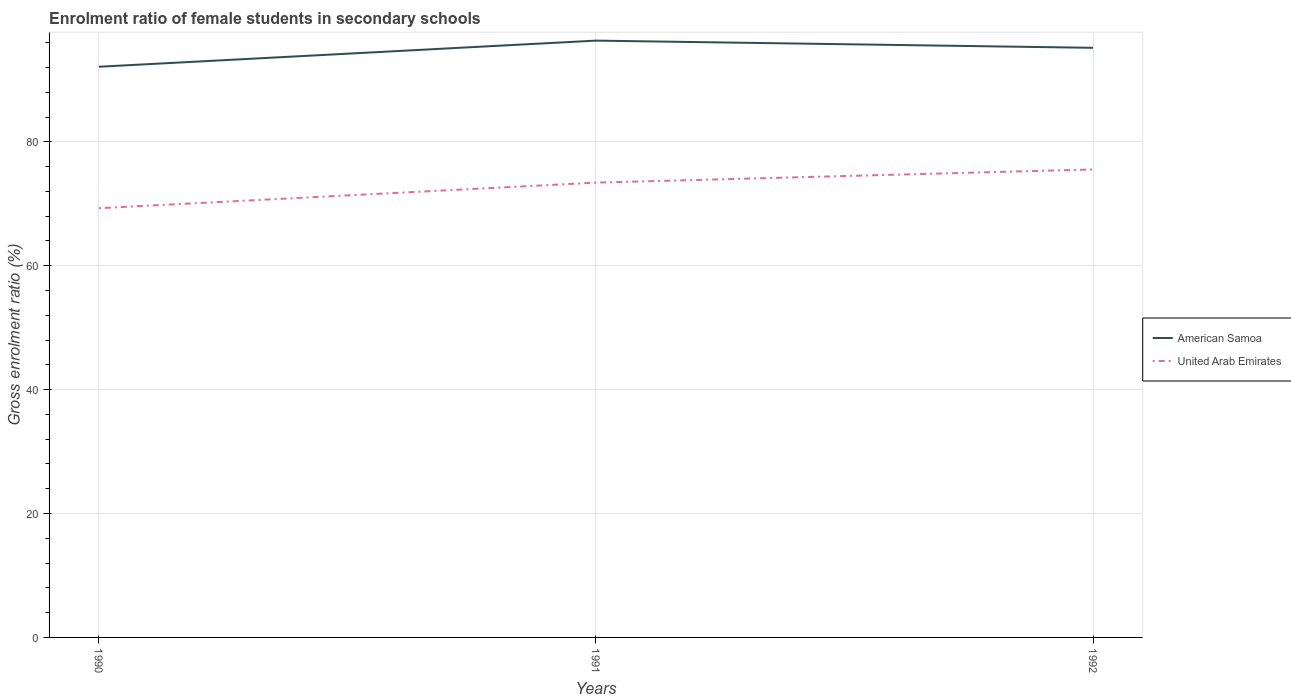Does the line corresponding to American Samoa intersect with the line corresponding to United Arab Emirates?
Ensure brevity in your answer.  No. Is the number of lines equal to the number of legend labels?
Ensure brevity in your answer.  Yes. Across all years, what is the maximum enrolment ratio of female students in secondary schools in United Arab Emirates?
Provide a succinct answer. 69.29. In which year was the enrolment ratio of female students in secondary schools in United Arab Emirates maximum?
Your response must be concise. 1990. What is the total enrolment ratio of female students in secondary schools in American Samoa in the graph?
Provide a succinct answer. -3.06. What is the difference between the highest and the second highest enrolment ratio of female students in secondary schools in American Samoa?
Your response must be concise. 4.22. Is the enrolment ratio of female students in secondary schools in United Arab Emirates strictly greater than the enrolment ratio of female students in secondary schools in American Samoa over the years?
Offer a very short reply. Yes. What is the difference between two consecutive major ticks on the Y-axis?
Your answer should be compact. 20. Are the values on the major ticks of Y-axis written in scientific E-notation?
Give a very brief answer. No. Does the graph contain grids?
Your response must be concise. Yes. How many legend labels are there?
Ensure brevity in your answer.  2. How are the legend labels stacked?
Keep it short and to the point. Vertical. What is the title of the graph?
Provide a succinct answer. Enrolment ratio of female students in secondary schools. What is the label or title of the X-axis?
Offer a terse response. Years. What is the Gross enrolment ratio (%) in American Samoa in 1990?
Ensure brevity in your answer.  92.13. What is the Gross enrolment ratio (%) of United Arab Emirates in 1990?
Offer a terse response. 69.29. What is the Gross enrolment ratio (%) of American Samoa in 1991?
Offer a very short reply. 96.34. What is the Gross enrolment ratio (%) in United Arab Emirates in 1991?
Provide a short and direct response. 73.42. What is the Gross enrolment ratio (%) in American Samoa in 1992?
Your answer should be very brief. 95.18. What is the Gross enrolment ratio (%) of United Arab Emirates in 1992?
Make the answer very short. 75.55. Across all years, what is the maximum Gross enrolment ratio (%) of American Samoa?
Your answer should be compact. 96.34. Across all years, what is the maximum Gross enrolment ratio (%) of United Arab Emirates?
Your answer should be compact. 75.55. Across all years, what is the minimum Gross enrolment ratio (%) in American Samoa?
Ensure brevity in your answer.  92.13. Across all years, what is the minimum Gross enrolment ratio (%) in United Arab Emirates?
Provide a succinct answer. 69.29. What is the total Gross enrolment ratio (%) in American Samoa in the graph?
Offer a very short reply. 283.66. What is the total Gross enrolment ratio (%) in United Arab Emirates in the graph?
Ensure brevity in your answer.  218.26. What is the difference between the Gross enrolment ratio (%) in American Samoa in 1990 and that in 1991?
Provide a succinct answer. -4.22. What is the difference between the Gross enrolment ratio (%) in United Arab Emirates in 1990 and that in 1991?
Keep it short and to the point. -4.13. What is the difference between the Gross enrolment ratio (%) in American Samoa in 1990 and that in 1992?
Make the answer very short. -3.06. What is the difference between the Gross enrolment ratio (%) of United Arab Emirates in 1990 and that in 1992?
Keep it short and to the point. -6.25. What is the difference between the Gross enrolment ratio (%) in American Samoa in 1991 and that in 1992?
Offer a very short reply. 1.16. What is the difference between the Gross enrolment ratio (%) of United Arab Emirates in 1991 and that in 1992?
Your response must be concise. -2.13. What is the difference between the Gross enrolment ratio (%) in American Samoa in 1990 and the Gross enrolment ratio (%) in United Arab Emirates in 1991?
Make the answer very short. 18.71. What is the difference between the Gross enrolment ratio (%) of American Samoa in 1990 and the Gross enrolment ratio (%) of United Arab Emirates in 1992?
Give a very brief answer. 16.58. What is the difference between the Gross enrolment ratio (%) of American Samoa in 1991 and the Gross enrolment ratio (%) of United Arab Emirates in 1992?
Your answer should be very brief. 20.8. What is the average Gross enrolment ratio (%) of American Samoa per year?
Your answer should be compact. 94.55. What is the average Gross enrolment ratio (%) in United Arab Emirates per year?
Keep it short and to the point. 72.75. In the year 1990, what is the difference between the Gross enrolment ratio (%) in American Samoa and Gross enrolment ratio (%) in United Arab Emirates?
Keep it short and to the point. 22.83. In the year 1991, what is the difference between the Gross enrolment ratio (%) of American Samoa and Gross enrolment ratio (%) of United Arab Emirates?
Your answer should be very brief. 22.92. In the year 1992, what is the difference between the Gross enrolment ratio (%) in American Samoa and Gross enrolment ratio (%) in United Arab Emirates?
Ensure brevity in your answer.  19.64. What is the ratio of the Gross enrolment ratio (%) in American Samoa in 1990 to that in 1991?
Ensure brevity in your answer.  0.96. What is the ratio of the Gross enrolment ratio (%) of United Arab Emirates in 1990 to that in 1991?
Your response must be concise. 0.94. What is the ratio of the Gross enrolment ratio (%) in American Samoa in 1990 to that in 1992?
Your answer should be very brief. 0.97. What is the ratio of the Gross enrolment ratio (%) in United Arab Emirates in 1990 to that in 1992?
Make the answer very short. 0.92. What is the ratio of the Gross enrolment ratio (%) of American Samoa in 1991 to that in 1992?
Offer a very short reply. 1.01. What is the ratio of the Gross enrolment ratio (%) in United Arab Emirates in 1991 to that in 1992?
Provide a succinct answer. 0.97. What is the difference between the highest and the second highest Gross enrolment ratio (%) of American Samoa?
Provide a short and direct response. 1.16. What is the difference between the highest and the second highest Gross enrolment ratio (%) of United Arab Emirates?
Ensure brevity in your answer.  2.13. What is the difference between the highest and the lowest Gross enrolment ratio (%) in American Samoa?
Your answer should be very brief. 4.22. What is the difference between the highest and the lowest Gross enrolment ratio (%) in United Arab Emirates?
Provide a succinct answer. 6.25. 